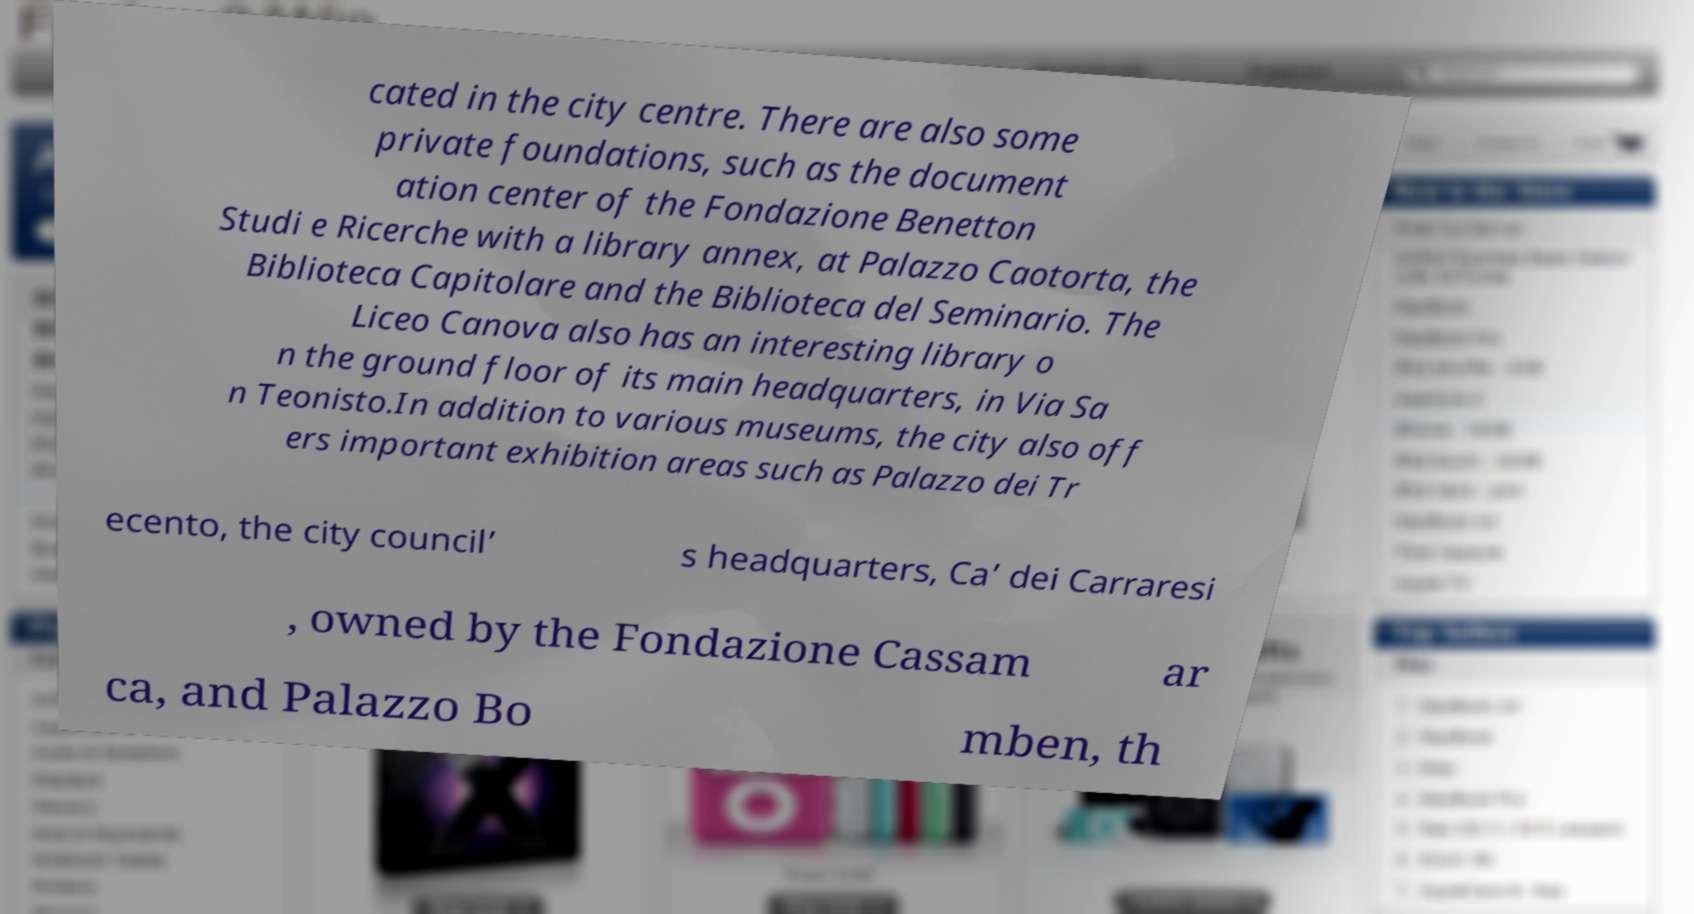Please read and relay the text visible in this image. What does it say? cated in the city centre. There are also some private foundations, such as the document ation center of the Fondazione Benetton Studi e Ricerche with a library annex, at Palazzo Caotorta, the Biblioteca Capitolare and the Biblioteca del Seminario. The Liceo Canova also has an interesting library o n the ground floor of its main headquarters, in Via Sa n Teonisto.In addition to various museums, the city also off ers important exhibition areas such as Palazzo dei Tr ecento, the city council’ s headquarters, Ca’ dei Carraresi , owned by the Fondazione Cassam ar ca, and Palazzo Bo mben, th 